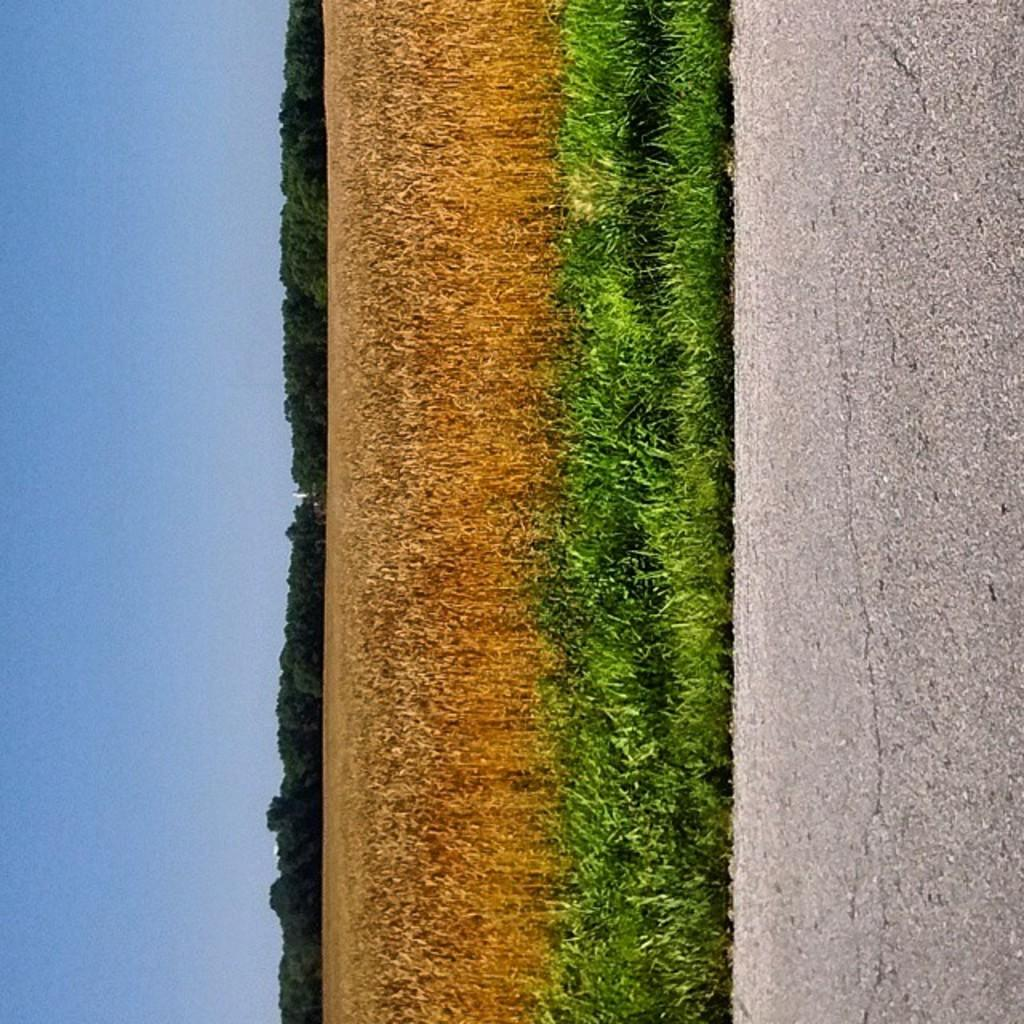What is the main feature of the image? There is a road in the image. What can be seen behind the road? There is green grass behind the road. What is located behind the grass? There is dry crop behind the grass. What is situated behind the dry crop? There are trees behind the dry crop. Can you tell me how many owls are sitting on the trees in the image? There are no owls present in the image; it only features a road, green grass, dry crop, and trees. 